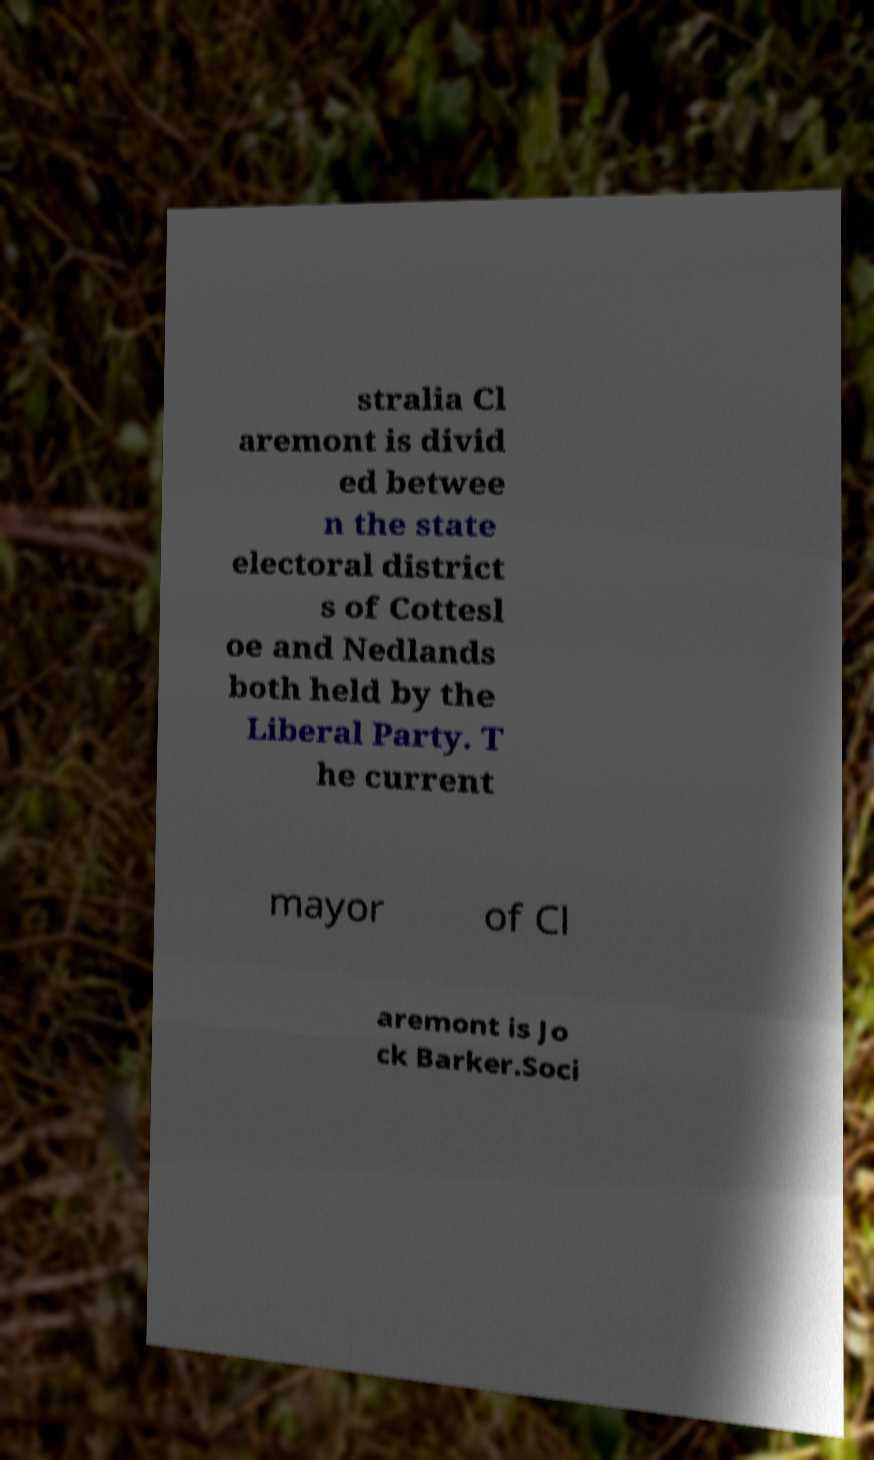Please identify and transcribe the text found in this image. stralia Cl aremont is divid ed betwee n the state electoral district s of Cottesl oe and Nedlands both held by the Liberal Party. T he current mayor of Cl aremont is Jo ck Barker.Soci 